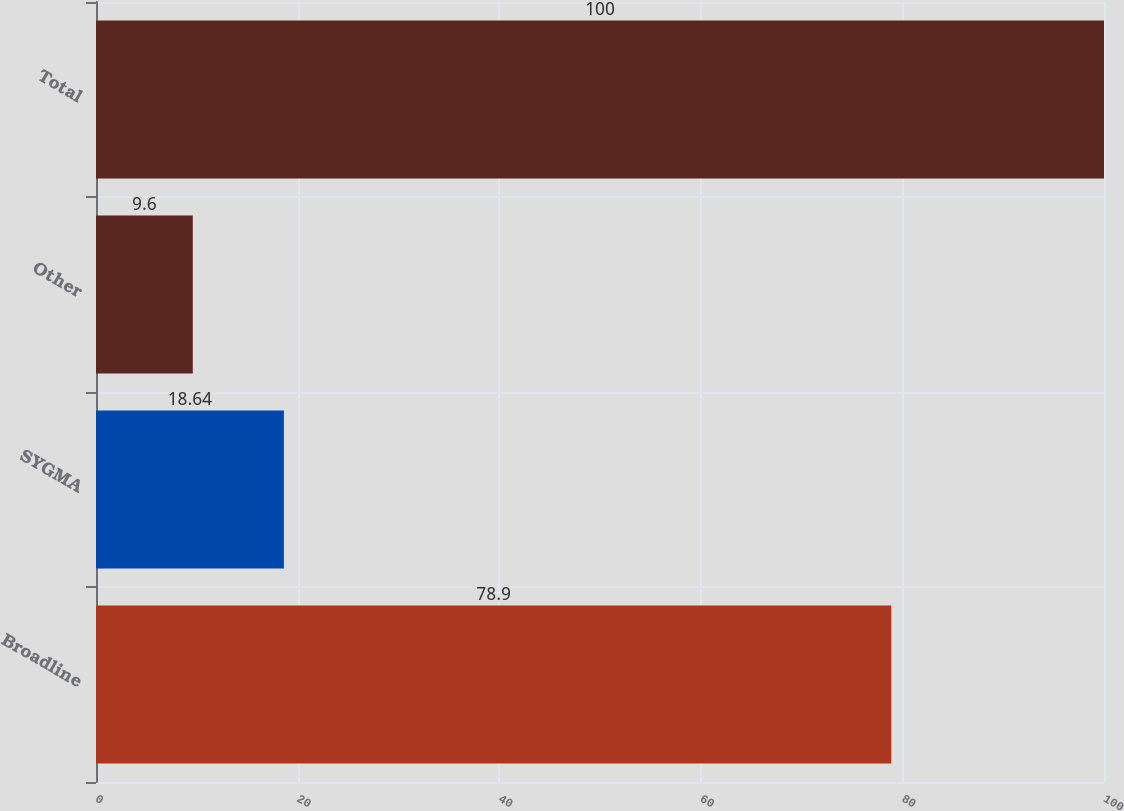<chart> <loc_0><loc_0><loc_500><loc_500><bar_chart><fcel>Broadline<fcel>SYGMA<fcel>Other<fcel>Total<nl><fcel>78.9<fcel>18.64<fcel>9.6<fcel>100<nl></chart> 